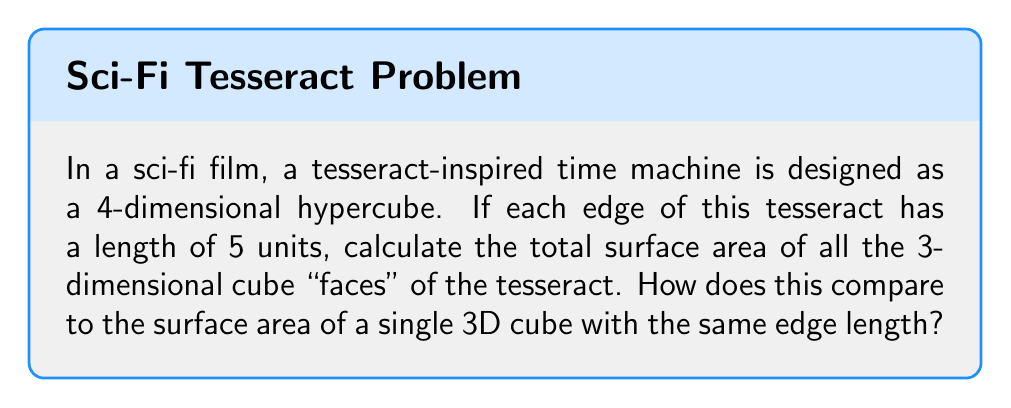Can you answer this question? Let's approach this step-by-step:

1) First, recall that a tesseract is a 4D analogue of a cube, composed of eight 3D cubes.

2) The surface area we're looking for is the sum of the surface areas of these eight 3D cubes.

3) For a single 3D cube with edge length $a$, the surface area is given by:
   
   $SA_{cube} = 6a^2$

4) In this case, $a = 5$, so the surface area of one cube is:
   
   $SA_{cube} = 6(5^2) = 6(25) = 150$ square units

5) Since there are 8 such cubes in a tesseract, the total surface area is:
   
   $SA_{tesseract} = 8 \times 150 = 1200$ square units

6) To compare this to a single 3D cube:
   
   $\frac{SA_{tesseract}}{SA_{cube}} = \frac{1200}{150} = 8$

This means the surface area of the tesseract-inspired time machine is 8 times that of a single 3D cube with the same edge length.

[asy]
import three;

size(200);
currentprojection=perspective(6,3,2);

triple A=(0,0,0), B=(5,0,0), C=(5,5,0), D=(0,5,0),
       E=(0,0,5), F=(5,0,5), G=(5,5,5), H=(0,5,5);

draw(A--B--C--D--cycle);
draw(E--F--G--H--cycle);
draw(A--E);
draw(B--F);
draw(C--G);
draw(D--H);

label("Cube", (2.5,2.5,-1));
[/asy]
Answer: 1200 square units; 8 times larger 